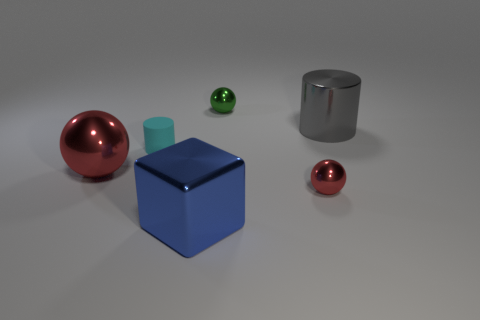Add 1 green shiny objects. How many objects exist? 7 Subtract all blocks. How many objects are left? 5 Subtract 0 red cylinders. How many objects are left? 6 Subtract all matte things. Subtract all red metal things. How many objects are left? 3 Add 6 green metallic things. How many green metallic things are left? 7 Add 2 blue shiny spheres. How many blue shiny spheres exist? 2 